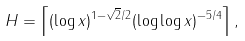<formula> <loc_0><loc_0><loc_500><loc_500>H = \left \lceil ( \log x ) ^ { 1 - \sqrt { 2 } / 2 } ( \log \log x ) ^ { - 5 / 4 } \right \rceil ,</formula> 